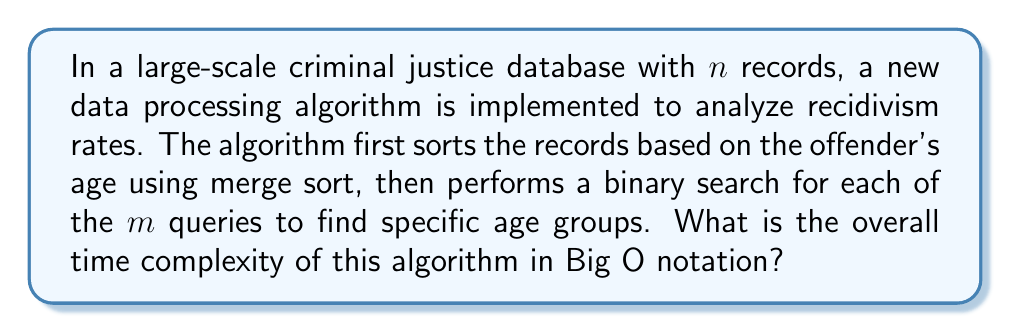Teach me how to tackle this problem. To determine the overall time complexity, we need to analyze each step of the algorithm:

1. Sorting the records:
   The algorithm uses merge sort to sort $n$ records based on the offender's age. The time complexity of merge sort is $O(n \log n)$.

2. Performing binary searches:
   For each of the $m$ queries, a binary search is performed on the sorted array of $n$ records. The time complexity of a single binary search is $O(\log n)$.
   Since there are $m$ queries, the total time complexity for all binary searches is $O(m \log n)$.

3. Combining the steps:
   The overall time complexity is the sum of the sorting step and the searching step:
   $O(n \log n + m \log n)$

4. Simplifying the expression:
   We can factor out the $\log n$ term:
   $O((n + m) \log n)$

This expression represents the worst-case time complexity of the algorithm. It's worth noting that in the context of criminal justice databases, $n$ (the number of records) is likely to be much larger than $m$ (the number of queries). However, without specific information about the relative sizes of $n$ and $m$, we cannot simplify the expression further.
Answer: $O((n + m) \log n)$ 